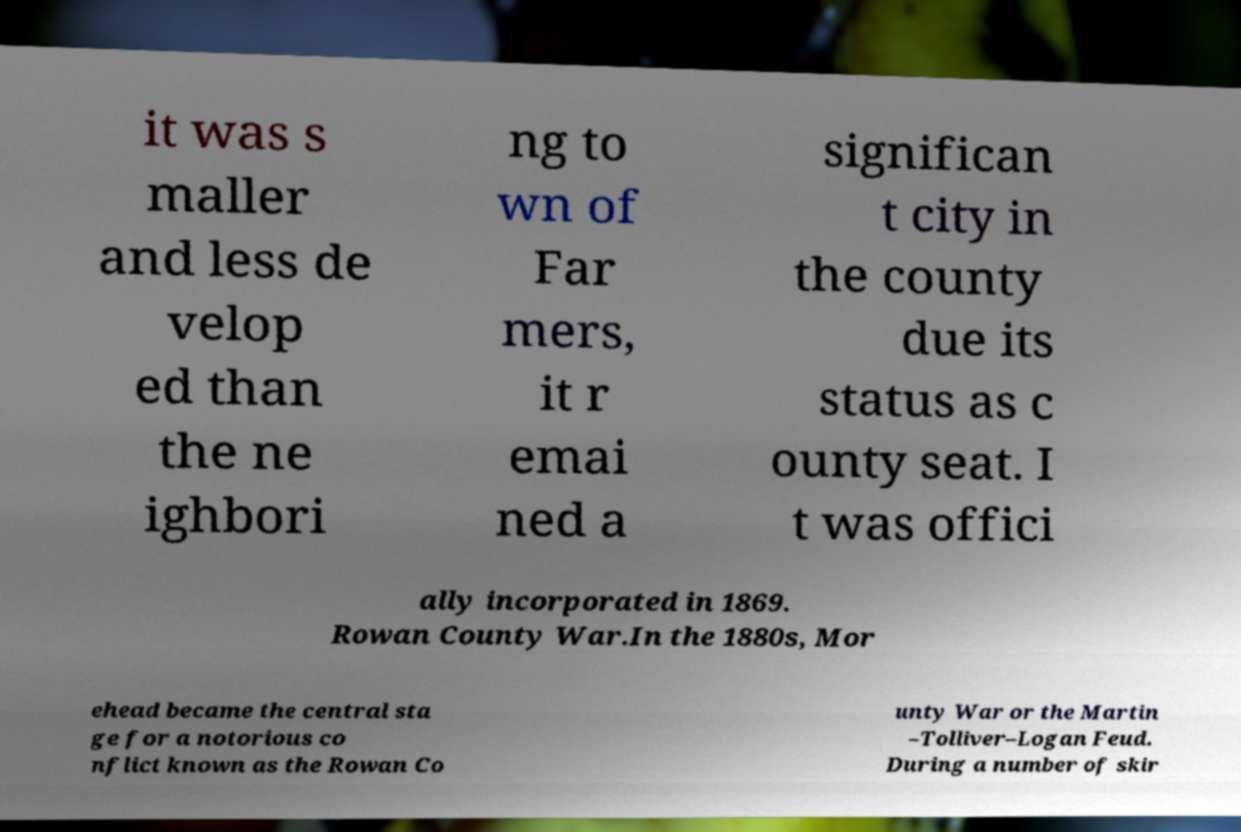For documentation purposes, I need the text within this image transcribed. Could you provide that? it was s maller and less de velop ed than the ne ighbori ng to wn of Far mers, it r emai ned a significan t city in the county due its status as c ounty seat. I t was offici ally incorporated in 1869. Rowan County War.In the 1880s, Mor ehead became the central sta ge for a notorious co nflict known as the Rowan Co unty War or the Martin –Tolliver–Logan Feud. During a number of skir 